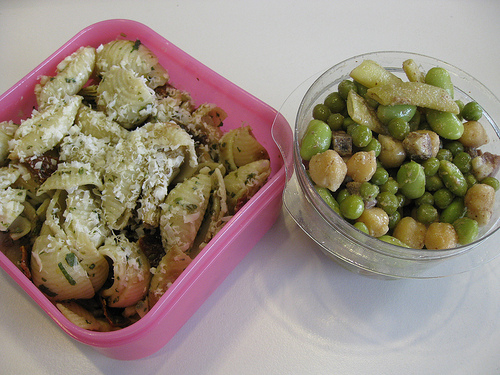<image>
Is there a green beans on the pasta? No. The green beans is not positioned on the pasta. They may be near each other, but the green beans is not supported by or resting on top of the pasta. 